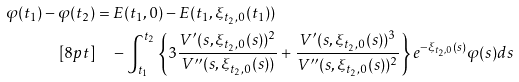<formula> <loc_0><loc_0><loc_500><loc_500>\varphi ( t _ { 1 } ) - \varphi ( t _ { 2 } ) & = E ( t _ { 1 } , 0 ) - E ( t _ { 1 } , \xi _ { t _ { 2 } , 0 } ( t _ { 1 } ) ) \\ [ 8 p t ] & \quad - \int _ { t _ { 1 } } ^ { t _ { 2 } } \left \{ 3 \frac { V ^ { \prime } ( s , \xi _ { t _ { 2 } , 0 } ( s ) ) ^ { 2 } } { V ^ { \prime \prime } ( s , \xi _ { t _ { 2 } , 0 } ( s ) ) } + \frac { V ^ { \prime } ( s , \xi _ { t _ { 2 } , 0 } ( s ) ) ^ { 3 } } { V ^ { \prime \prime } ( s , \xi _ { t _ { 2 } , 0 } ( s ) ) ^ { 2 } } \right \} e ^ { - \xi _ { t _ { 2 } , 0 } ( s ) } \varphi ( s ) d s</formula> 